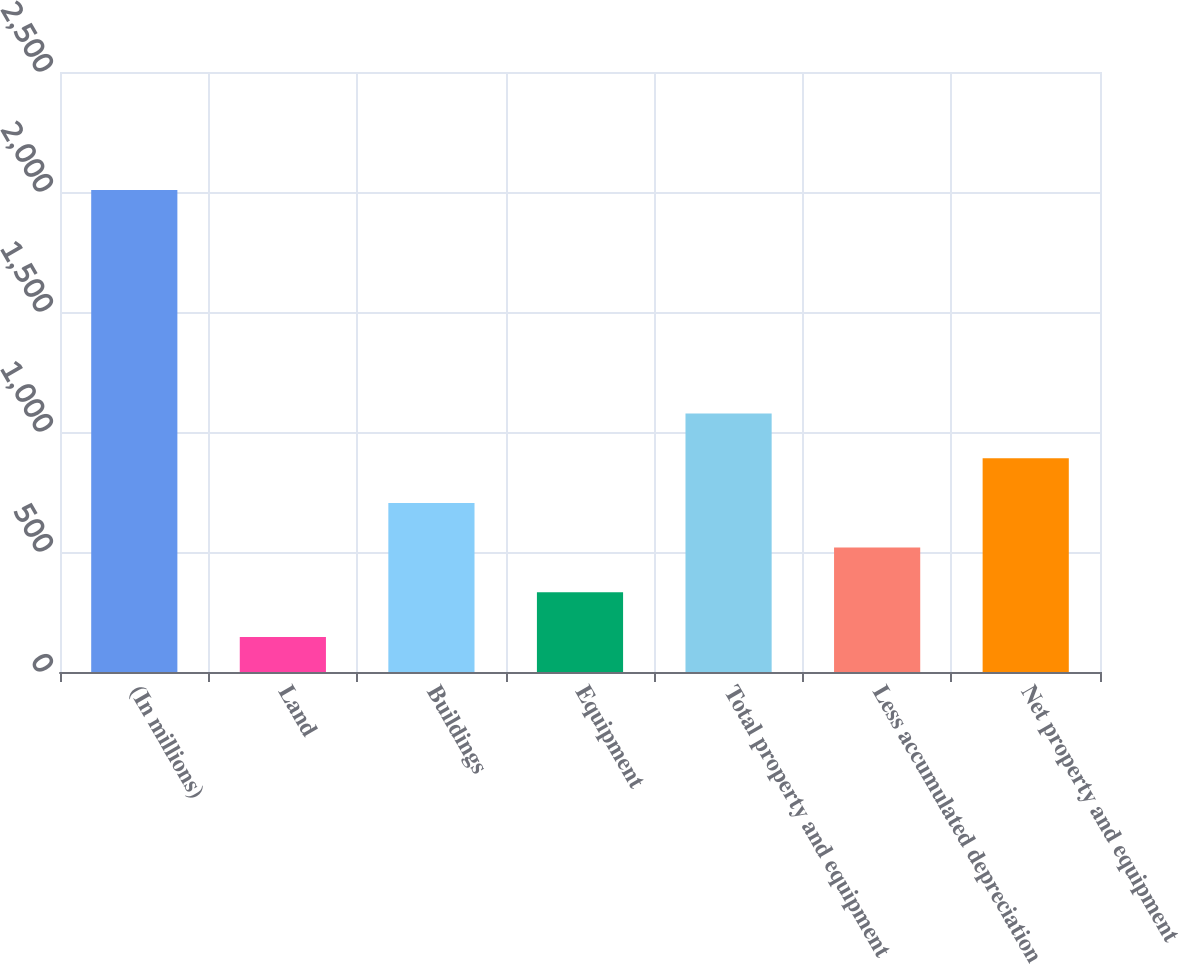<chart> <loc_0><loc_0><loc_500><loc_500><bar_chart><fcel>(In millions)<fcel>Land<fcel>Buildings<fcel>Equipment<fcel>Total property and equipment<fcel>Less accumulated depreciation<fcel>Net property and equipment<nl><fcel>2008<fcel>146<fcel>704.6<fcel>332.2<fcel>1077<fcel>518.4<fcel>890.8<nl></chart> 